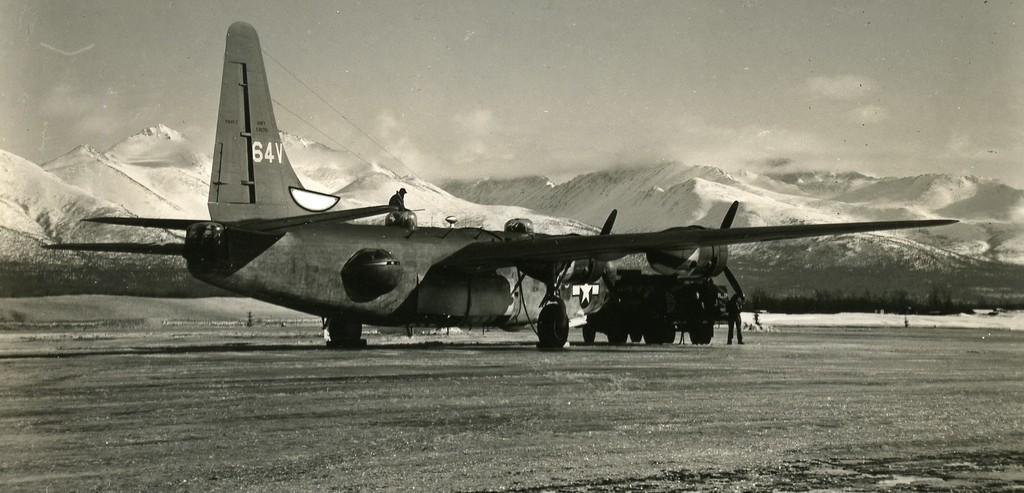In one or two sentences, can you explain what this image depicts? In the foreground of this image, there is a plane on the ground and we can also see a man standing and a man on the top of it. In the background, there are mountains and the sky. 